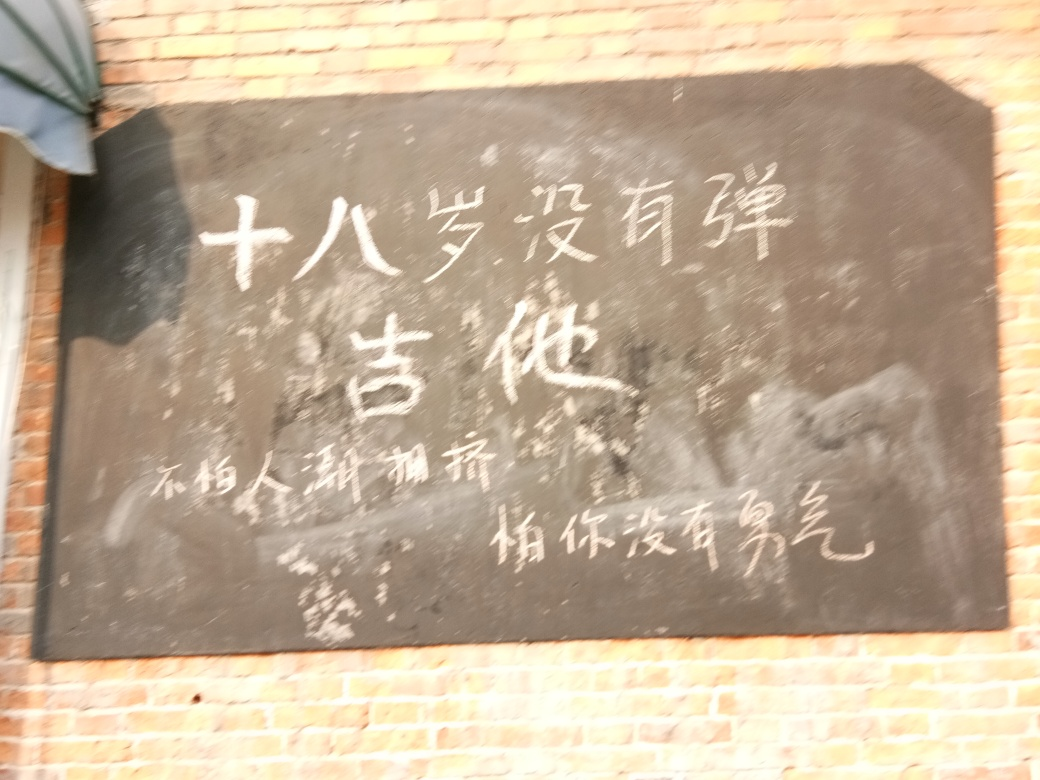How could the clarity of this image be improved? Improving the image's clarity would involve reducing the blur and glare that currently affect its quality. This could be done by steadying the camera during capture, using better lighting conditions, or employing image stabilization and focus features more precisely. 